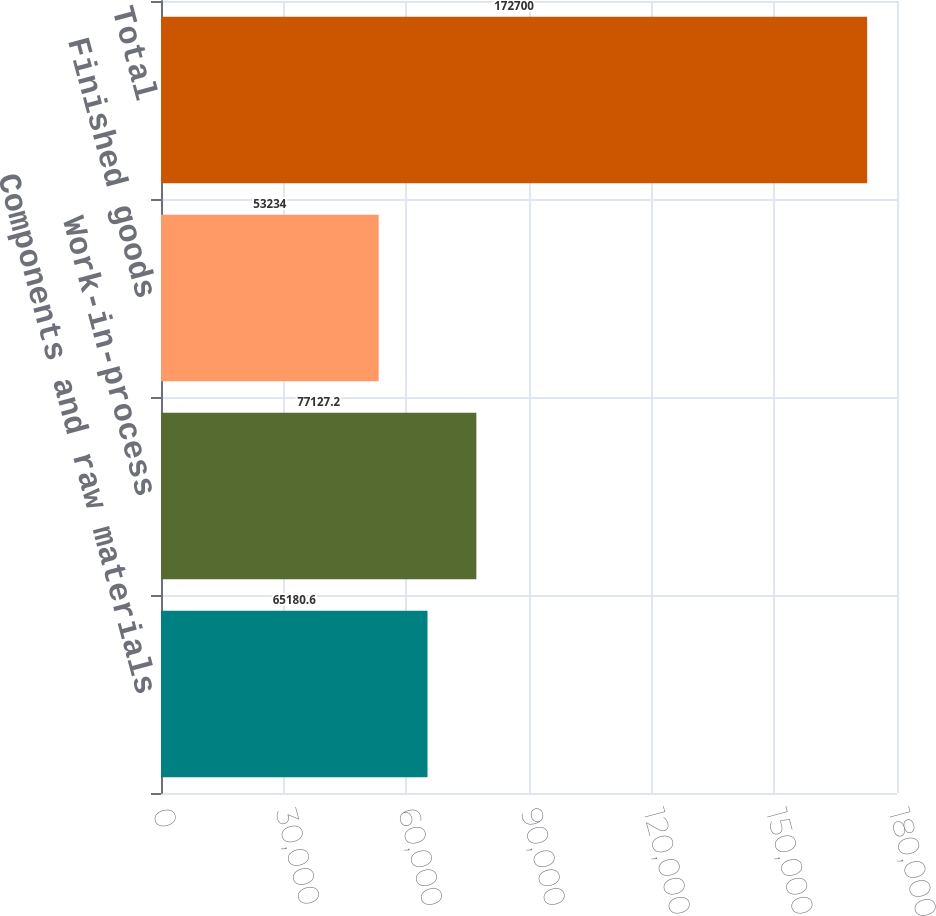<chart> <loc_0><loc_0><loc_500><loc_500><bar_chart><fcel>Components and raw materials<fcel>Work-in-process<fcel>Finished goods<fcel>Total<nl><fcel>65180.6<fcel>77127.2<fcel>53234<fcel>172700<nl></chart> 